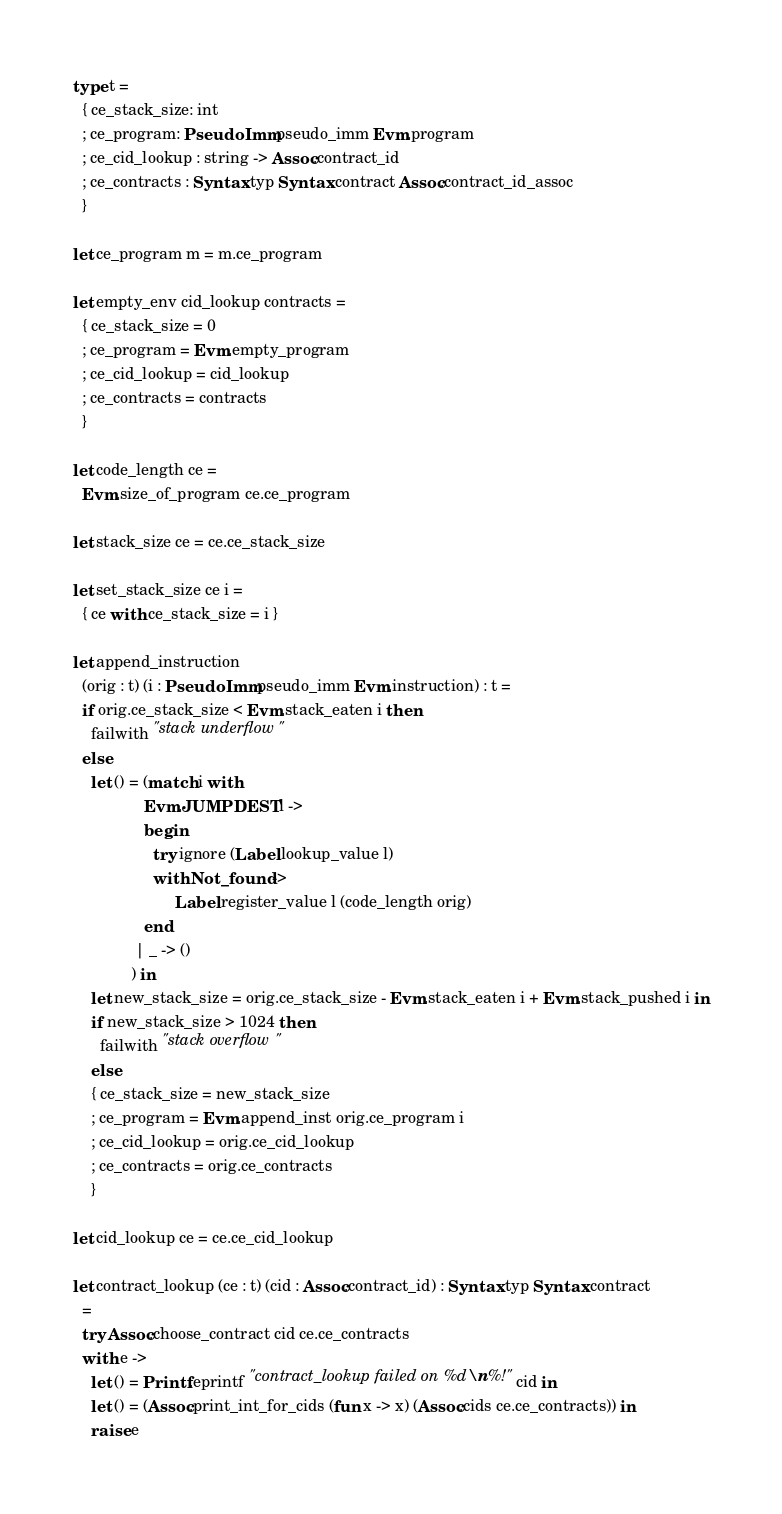Convert code to text. <code><loc_0><loc_0><loc_500><loc_500><_OCaml_>type t =
  { ce_stack_size: int
  ; ce_program: PseudoImm.pseudo_imm Evm.program
  ; ce_cid_lookup : string -> Assoc.contract_id
  ; ce_contracts : Syntax.typ Syntax.contract Assoc.contract_id_assoc
  }

let ce_program m = m.ce_program

let empty_env cid_lookup contracts =
  { ce_stack_size = 0
  ; ce_program = Evm.empty_program
  ; ce_cid_lookup = cid_lookup
  ; ce_contracts = contracts
  }

let code_length ce =
  Evm.size_of_program ce.ce_program

let stack_size ce = ce.ce_stack_size

let set_stack_size ce i =
  { ce with ce_stack_size = i }

let append_instruction
  (orig : t) (i : PseudoImm.pseudo_imm Evm.instruction) : t =
  if orig.ce_stack_size < Evm.stack_eaten i then
    failwith "stack underflow"
  else
    let () = (match i with
                Evm.JUMPDEST l ->
                begin
                  try ignore (Label.lookup_value l)
                  with Not_found ->
                       Label.register_value l (code_length orig)
                end
              | _ -> ()
             ) in
    let new_stack_size = orig.ce_stack_size - Evm.stack_eaten i + Evm.stack_pushed i in
    if new_stack_size > 1024 then
      failwith "stack overflow"
    else
    { ce_stack_size = new_stack_size
    ; ce_program = Evm.append_inst orig.ce_program i
    ; ce_cid_lookup = orig.ce_cid_lookup
    ; ce_contracts = orig.ce_contracts
    }

let cid_lookup ce = ce.ce_cid_lookup

let contract_lookup (ce : t) (cid : Assoc.contract_id) : Syntax.typ Syntax.contract
  =
  try Assoc.choose_contract cid ce.ce_contracts
  with e ->
    let () = Printf.eprintf "contract_lookup failed on %d\n%!" cid in
    let () = (Assoc.print_int_for_cids (fun x -> x) (Assoc.cids ce.ce_contracts)) in
    raise e
</code> 